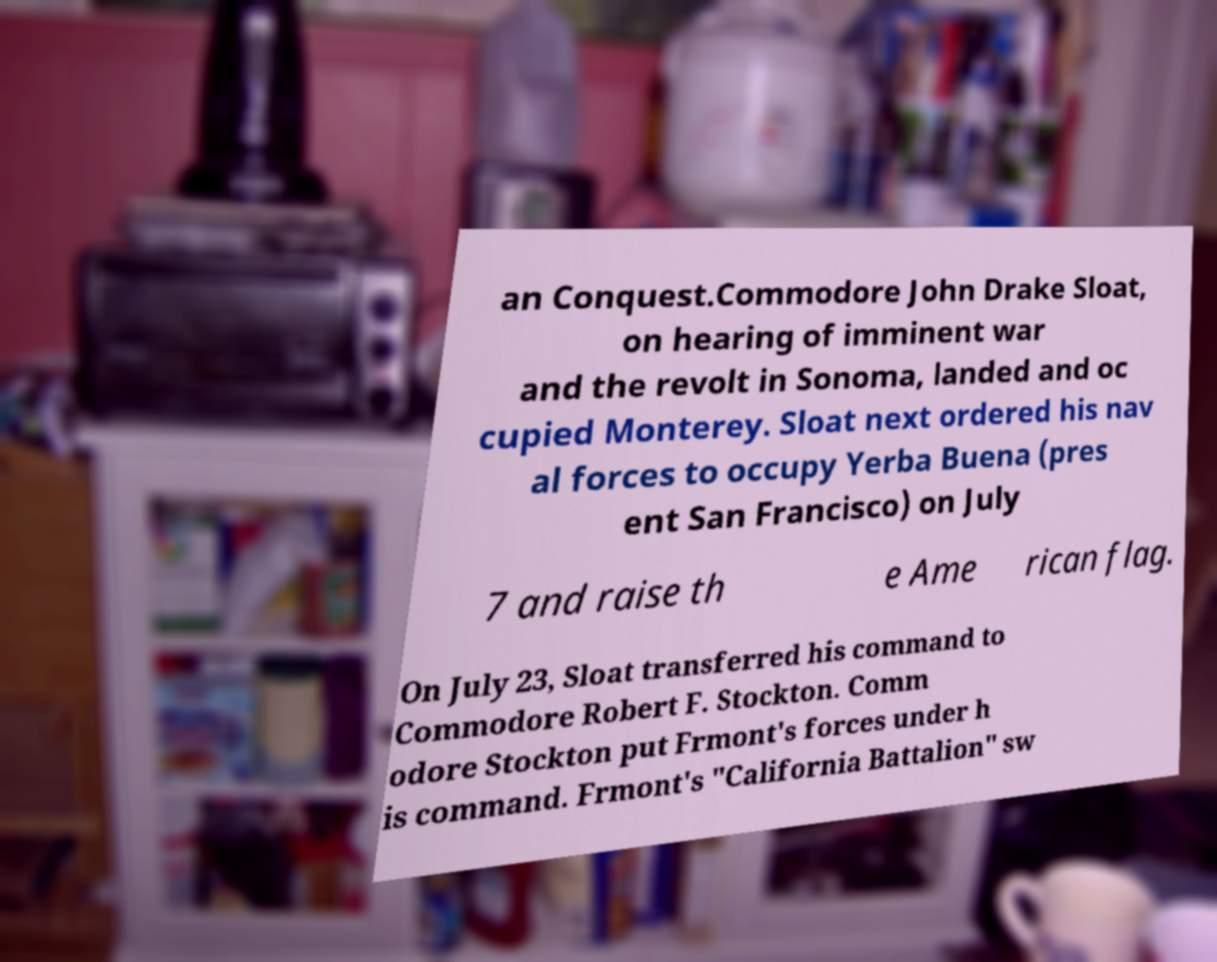Please identify and transcribe the text found in this image. an Conquest.Commodore John Drake Sloat, on hearing of imminent war and the revolt in Sonoma, landed and oc cupied Monterey. Sloat next ordered his nav al forces to occupy Yerba Buena (pres ent San Francisco) on July 7 and raise th e Ame rican flag. On July 23, Sloat transferred his command to Commodore Robert F. Stockton. Comm odore Stockton put Frmont's forces under h is command. Frmont's "California Battalion" sw 